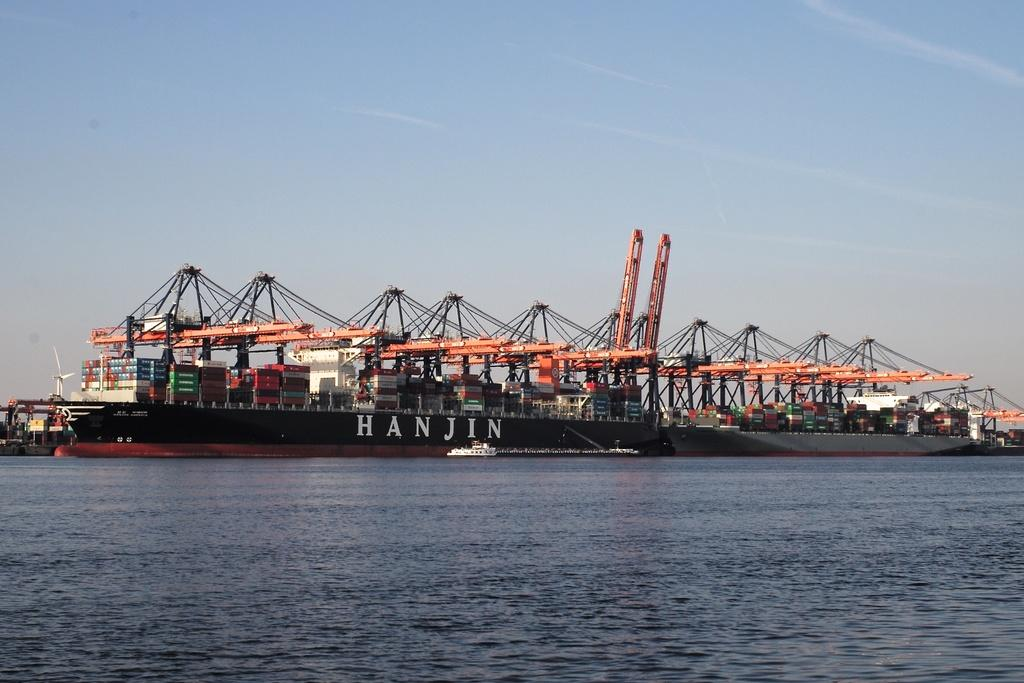Provide a one-sentence caption for the provided image. A small white boat is near the big ship called HANJIN. 